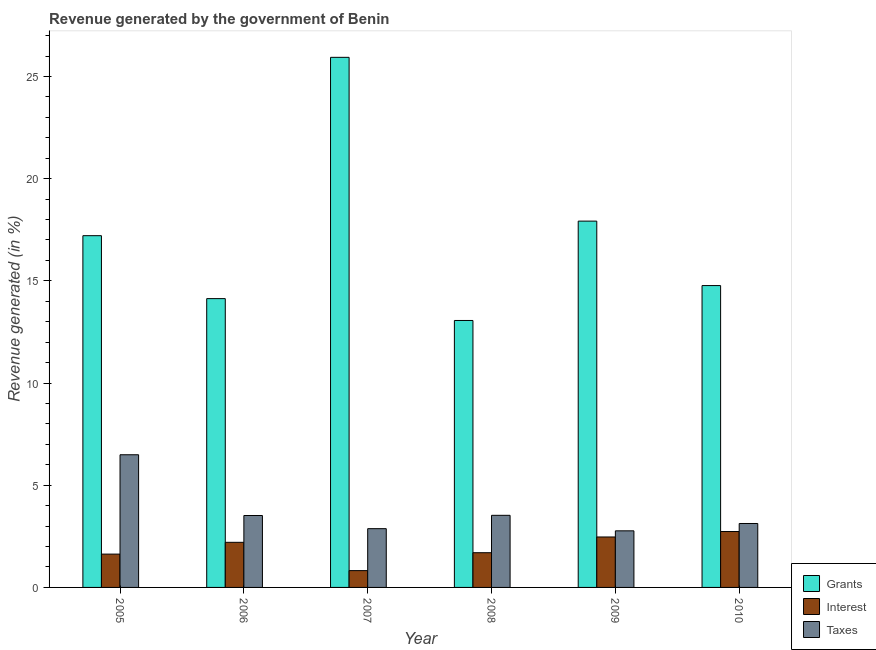Are the number of bars on each tick of the X-axis equal?
Your response must be concise. Yes. What is the percentage of revenue generated by grants in 2010?
Your answer should be compact. 14.77. Across all years, what is the maximum percentage of revenue generated by taxes?
Give a very brief answer. 6.49. Across all years, what is the minimum percentage of revenue generated by grants?
Keep it short and to the point. 13.06. In which year was the percentage of revenue generated by interest maximum?
Your answer should be compact. 2010. In which year was the percentage of revenue generated by interest minimum?
Provide a short and direct response. 2007. What is the total percentage of revenue generated by grants in the graph?
Provide a succinct answer. 103.03. What is the difference between the percentage of revenue generated by grants in 2008 and that in 2009?
Your answer should be compact. -4.86. What is the difference between the percentage of revenue generated by grants in 2006 and the percentage of revenue generated by interest in 2008?
Make the answer very short. 1.07. What is the average percentage of revenue generated by interest per year?
Give a very brief answer. 1.93. In the year 2007, what is the difference between the percentage of revenue generated by interest and percentage of revenue generated by grants?
Provide a succinct answer. 0. What is the ratio of the percentage of revenue generated by interest in 2005 to that in 2010?
Offer a very short reply. 0.6. What is the difference between the highest and the second highest percentage of revenue generated by taxes?
Provide a succinct answer. 2.96. What is the difference between the highest and the lowest percentage of revenue generated by grants?
Keep it short and to the point. 12.87. In how many years, is the percentage of revenue generated by grants greater than the average percentage of revenue generated by grants taken over all years?
Keep it short and to the point. 3. Is the sum of the percentage of revenue generated by taxes in 2006 and 2009 greater than the maximum percentage of revenue generated by interest across all years?
Your response must be concise. No. What does the 1st bar from the left in 2008 represents?
Ensure brevity in your answer.  Grants. What does the 2nd bar from the right in 2007 represents?
Ensure brevity in your answer.  Interest. How many bars are there?
Give a very brief answer. 18. How many years are there in the graph?
Offer a very short reply. 6. Are the values on the major ticks of Y-axis written in scientific E-notation?
Your answer should be very brief. No. Does the graph contain any zero values?
Give a very brief answer. No. Does the graph contain grids?
Keep it short and to the point. No. What is the title of the graph?
Provide a short and direct response. Revenue generated by the government of Benin. What is the label or title of the X-axis?
Ensure brevity in your answer.  Year. What is the label or title of the Y-axis?
Provide a succinct answer. Revenue generated (in %). What is the Revenue generated (in %) of Grants in 2005?
Offer a very short reply. 17.21. What is the Revenue generated (in %) of Interest in 2005?
Your answer should be compact. 1.63. What is the Revenue generated (in %) of Taxes in 2005?
Make the answer very short. 6.49. What is the Revenue generated (in %) of Grants in 2006?
Ensure brevity in your answer.  14.13. What is the Revenue generated (in %) of Interest in 2006?
Offer a very short reply. 2.21. What is the Revenue generated (in %) in Taxes in 2006?
Keep it short and to the point. 3.52. What is the Revenue generated (in %) of Grants in 2007?
Your response must be concise. 25.94. What is the Revenue generated (in %) in Interest in 2007?
Provide a short and direct response. 0.82. What is the Revenue generated (in %) of Taxes in 2007?
Offer a terse response. 2.88. What is the Revenue generated (in %) in Grants in 2008?
Offer a very short reply. 13.06. What is the Revenue generated (in %) of Interest in 2008?
Provide a short and direct response. 1.7. What is the Revenue generated (in %) of Taxes in 2008?
Keep it short and to the point. 3.53. What is the Revenue generated (in %) of Grants in 2009?
Keep it short and to the point. 17.92. What is the Revenue generated (in %) in Interest in 2009?
Offer a terse response. 2.47. What is the Revenue generated (in %) of Taxes in 2009?
Your answer should be compact. 2.77. What is the Revenue generated (in %) of Grants in 2010?
Your answer should be compact. 14.77. What is the Revenue generated (in %) in Interest in 2010?
Provide a short and direct response. 2.74. What is the Revenue generated (in %) in Taxes in 2010?
Make the answer very short. 3.13. Across all years, what is the maximum Revenue generated (in %) in Grants?
Keep it short and to the point. 25.94. Across all years, what is the maximum Revenue generated (in %) in Interest?
Give a very brief answer. 2.74. Across all years, what is the maximum Revenue generated (in %) of Taxes?
Make the answer very short. 6.49. Across all years, what is the minimum Revenue generated (in %) in Grants?
Your answer should be compact. 13.06. Across all years, what is the minimum Revenue generated (in %) of Interest?
Provide a short and direct response. 0.82. Across all years, what is the minimum Revenue generated (in %) of Taxes?
Your response must be concise. 2.77. What is the total Revenue generated (in %) in Grants in the graph?
Your response must be concise. 103.03. What is the total Revenue generated (in %) in Interest in the graph?
Keep it short and to the point. 11.56. What is the total Revenue generated (in %) of Taxes in the graph?
Provide a short and direct response. 22.31. What is the difference between the Revenue generated (in %) of Grants in 2005 and that in 2006?
Provide a short and direct response. 3.08. What is the difference between the Revenue generated (in %) of Interest in 2005 and that in 2006?
Make the answer very short. -0.58. What is the difference between the Revenue generated (in %) of Taxes in 2005 and that in 2006?
Keep it short and to the point. 2.97. What is the difference between the Revenue generated (in %) in Grants in 2005 and that in 2007?
Provide a succinct answer. -8.73. What is the difference between the Revenue generated (in %) of Interest in 2005 and that in 2007?
Ensure brevity in your answer.  0.81. What is the difference between the Revenue generated (in %) of Taxes in 2005 and that in 2007?
Offer a very short reply. 3.62. What is the difference between the Revenue generated (in %) in Grants in 2005 and that in 2008?
Give a very brief answer. 4.15. What is the difference between the Revenue generated (in %) of Interest in 2005 and that in 2008?
Your answer should be very brief. -0.07. What is the difference between the Revenue generated (in %) in Taxes in 2005 and that in 2008?
Your answer should be very brief. 2.96. What is the difference between the Revenue generated (in %) of Grants in 2005 and that in 2009?
Offer a very short reply. -0.71. What is the difference between the Revenue generated (in %) of Interest in 2005 and that in 2009?
Your answer should be very brief. -0.84. What is the difference between the Revenue generated (in %) of Taxes in 2005 and that in 2009?
Provide a succinct answer. 3.72. What is the difference between the Revenue generated (in %) of Grants in 2005 and that in 2010?
Your response must be concise. 2.44. What is the difference between the Revenue generated (in %) in Interest in 2005 and that in 2010?
Your answer should be very brief. -1.1. What is the difference between the Revenue generated (in %) in Taxes in 2005 and that in 2010?
Provide a succinct answer. 3.36. What is the difference between the Revenue generated (in %) of Grants in 2006 and that in 2007?
Provide a short and direct response. -11.81. What is the difference between the Revenue generated (in %) of Interest in 2006 and that in 2007?
Provide a succinct answer. 1.38. What is the difference between the Revenue generated (in %) of Taxes in 2006 and that in 2007?
Keep it short and to the point. 0.64. What is the difference between the Revenue generated (in %) of Grants in 2006 and that in 2008?
Offer a terse response. 1.07. What is the difference between the Revenue generated (in %) of Interest in 2006 and that in 2008?
Make the answer very short. 0.51. What is the difference between the Revenue generated (in %) in Taxes in 2006 and that in 2008?
Provide a short and direct response. -0.01. What is the difference between the Revenue generated (in %) of Grants in 2006 and that in 2009?
Make the answer very short. -3.79. What is the difference between the Revenue generated (in %) of Interest in 2006 and that in 2009?
Ensure brevity in your answer.  -0.26. What is the difference between the Revenue generated (in %) in Grants in 2006 and that in 2010?
Your answer should be compact. -0.64. What is the difference between the Revenue generated (in %) in Interest in 2006 and that in 2010?
Your response must be concise. -0.53. What is the difference between the Revenue generated (in %) in Taxes in 2006 and that in 2010?
Your response must be concise. 0.39. What is the difference between the Revenue generated (in %) in Grants in 2007 and that in 2008?
Your answer should be compact. 12.87. What is the difference between the Revenue generated (in %) in Interest in 2007 and that in 2008?
Make the answer very short. -0.88. What is the difference between the Revenue generated (in %) in Taxes in 2007 and that in 2008?
Your response must be concise. -0.65. What is the difference between the Revenue generated (in %) in Grants in 2007 and that in 2009?
Your answer should be compact. 8.01. What is the difference between the Revenue generated (in %) in Interest in 2007 and that in 2009?
Provide a succinct answer. -1.65. What is the difference between the Revenue generated (in %) in Taxes in 2007 and that in 2009?
Give a very brief answer. 0.11. What is the difference between the Revenue generated (in %) of Grants in 2007 and that in 2010?
Your answer should be very brief. 11.17. What is the difference between the Revenue generated (in %) in Interest in 2007 and that in 2010?
Your answer should be compact. -1.91. What is the difference between the Revenue generated (in %) of Taxes in 2007 and that in 2010?
Ensure brevity in your answer.  -0.25. What is the difference between the Revenue generated (in %) in Grants in 2008 and that in 2009?
Your answer should be compact. -4.86. What is the difference between the Revenue generated (in %) in Interest in 2008 and that in 2009?
Your answer should be compact. -0.77. What is the difference between the Revenue generated (in %) in Taxes in 2008 and that in 2009?
Make the answer very short. 0.76. What is the difference between the Revenue generated (in %) of Grants in 2008 and that in 2010?
Make the answer very short. -1.71. What is the difference between the Revenue generated (in %) of Interest in 2008 and that in 2010?
Ensure brevity in your answer.  -1.04. What is the difference between the Revenue generated (in %) in Taxes in 2008 and that in 2010?
Keep it short and to the point. 0.4. What is the difference between the Revenue generated (in %) in Grants in 2009 and that in 2010?
Ensure brevity in your answer.  3.15. What is the difference between the Revenue generated (in %) in Interest in 2009 and that in 2010?
Make the answer very short. -0.27. What is the difference between the Revenue generated (in %) in Taxes in 2009 and that in 2010?
Make the answer very short. -0.36. What is the difference between the Revenue generated (in %) of Grants in 2005 and the Revenue generated (in %) of Interest in 2006?
Keep it short and to the point. 15. What is the difference between the Revenue generated (in %) of Grants in 2005 and the Revenue generated (in %) of Taxes in 2006?
Ensure brevity in your answer.  13.69. What is the difference between the Revenue generated (in %) of Interest in 2005 and the Revenue generated (in %) of Taxes in 2006?
Offer a terse response. -1.89. What is the difference between the Revenue generated (in %) of Grants in 2005 and the Revenue generated (in %) of Interest in 2007?
Give a very brief answer. 16.39. What is the difference between the Revenue generated (in %) in Grants in 2005 and the Revenue generated (in %) in Taxes in 2007?
Make the answer very short. 14.33. What is the difference between the Revenue generated (in %) in Interest in 2005 and the Revenue generated (in %) in Taxes in 2007?
Provide a succinct answer. -1.25. What is the difference between the Revenue generated (in %) of Grants in 2005 and the Revenue generated (in %) of Interest in 2008?
Offer a very short reply. 15.51. What is the difference between the Revenue generated (in %) of Grants in 2005 and the Revenue generated (in %) of Taxes in 2008?
Provide a succinct answer. 13.68. What is the difference between the Revenue generated (in %) of Interest in 2005 and the Revenue generated (in %) of Taxes in 2008?
Provide a short and direct response. -1.9. What is the difference between the Revenue generated (in %) in Grants in 2005 and the Revenue generated (in %) in Interest in 2009?
Your response must be concise. 14.74. What is the difference between the Revenue generated (in %) in Grants in 2005 and the Revenue generated (in %) in Taxes in 2009?
Ensure brevity in your answer.  14.44. What is the difference between the Revenue generated (in %) in Interest in 2005 and the Revenue generated (in %) in Taxes in 2009?
Make the answer very short. -1.14. What is the difference between the Revenue generated (in %) in Grants in 2005 and the Revenue generated (in %) in Interest in 2010?
Provide a short and direct response. 14.47. What is the difference between the Revenue generated (in %) in Grants in 2005 and the Revenue generated (in %) in Taxes in 2010?
Provide a succinct answer. 14.08. What is the difference between the Revenue generated (in %) of Interest in 2005 and the Revenue generated (in %) of Taxes in 2010?
Give a very brief answer. -1.5. What is the difference between the Revenue generated (in %) of Grants in 2006 and the Revenue generated (in %) of Interest in 2007?
Offer a terse response. 13.31. What is the difference between the Revenue generated (in %) of Grants in 2006 and the Revenue generated (in %) of Taxes in 2007?
Your response must be concise. 11.25. What is the difference between the Revenue generated (in %) in Interest in 2006 and the Revenue generated (in %) in Taxes in 2007?
Your response must be concise. -0.67. What is the difference between the Revenue generated (in %) of Grants in 2006 and the Revenue generated (in %) of Interest in 2008?
Make the answer very short. 12.43. What is the difference between the Revenue generated (in %) in Grants in 2006 and the Revenue generated (in %) in Taxes in 2008?
Make the answer very short. 10.6. What is the difference between the Revenue generated (in %) of Interest in 2006 and the Revenue generated (in %) of Taxes in 2008?
Offer a very short reply. -1.32. What is the difference between the Revenue generated (in %) in Grants in 2006 and the Revenue generated (in %) in Interest in 2009?
Ensure brevity in your answer.  11.66. What is the difference between the Revenue generated (in %) of Grants in 2006 and the Revenue generated (in %) of Taxes in 2009?
Ensure brevity in your answer.  11.36. What is the difference between the Revenue generated (in %) in Interest in 2006 and the Revenue generated (in %) in Taxes in 2009?
Your answer should be very brief. -0.56. What is the difference between the Revenue generated (in %) in Grants in 2006 and the Revenue generated (in %) in Interest in 2010?
Make the answer very short. 11.39. What is the difference between the Revenue generated (in %) of Grants in 2006 and the Revenue generated (in %) of Taxes in 2010?
Keep it short and to the point. 11. What is the difference between the Revenue generated (in %) of Interest in 2006 and the Revenue generated (in %) of Taxes in 2010?
Ensure brevity in your answer.  -0.92. What is the difference between the Revenue generated (in %) in Grants in 2007 and the Revenue generated (in %) in Interest in 2008?
Provide a short and direct response. 24.24. What is the difference between the Revenue generated (in %) of Grants in 2007 and the Revenue generated (in %) of Taxes in 2008?
Your answer should be very brief. 22.41. What is the difference between the Revenue generated (in %) in Interest in 2007 and the Revenue generated (in %) in Taxes in 2008?
Keep it short and to the point. -2.71. What is the difference between the Revenue generated (in %) in Grants in 2007 and the Revenue generated (in %) in Interest in 2009?
Keep it short and to the point. 23.47. What is the difference between the Revenue generated (in %) in Grants in 2007 and the Revenue generated (in %) in Taxes in 2009?
Your response must be concise. 23.17. What is the difference between the Revenue generated (in %) of Interest in 2007 and the Revenue generated (in %) of Taxes in 2009?
Your response must be concise. -1.95. What is the difference between the Revenue generated (in %) of Grants in 2007 and the Revenue generated (in %) of Interest in 2010?
Provide a short and direct response. 23.2. What is the difference between the Revenue generated (in %) of Grants in 2007 and the Revenue generated (in %) of Taxes in 2010?
Offer a terse response. 22.81. What is the difference between the Revenue generated (in %) in Interest in 2007 and the Revenue generated (in %) in Taxes in 2010?
Your answer should be compact. -2.31. What is the difference between the Revenue generated (in %) of Grants in 2008 and the Revenue generated (in %) of Interest in 2009?
Your response must be concise. 10.59. What is the difference between the Revenue generated (in %) in Grants in 2008 and the Revenue generated (in %) in Taxes in 2009?
Your response must be concise. 10.29. What is the difference between the Revenue generated (in %) in Interest in 2008 and the Revenue generated (in %) in Taxes in 2009?
Offer a terse response. -1.07. What is the difference between the Revenue generated (in %) in Grants in 2008 and the Revenue generated (in %) in Interest in 2010?
Your answer should be very brief. 10.33. What is the difference between the Revenue generated (in %) of Grants in 2008 and the Revenue generated (in %) of Taxes in 2010?
Keep it short and to the point. 9.93. What is the difference between the Revenue generated (in %) in Interest in 2008 and the Revenue generated (in %) in Taxes in 2010?
Give a very brief answer. -1.43. What is the difference between the Revenue generated (in %) of Grants in 2009 and the Revenue generated (in %) of Interest in 2010?
Provide a short and direct response. 15.19. What is the difference between the Revenue generated (in %) of Grants in 2009 and the Revenue generated (in %) of Taxes in 2010?
Offer a terse response. 14.79. What is the difference between the Revenue generated (in %) in Interest in 2009 and the Revenue generated (in %) in Taxes in 2010?
Your answer should be very brief. -0.66. What is the average Revenue generated (in %) in Grants per year?
Keep it short and to the point. 17.17. What is the average Revenue generated (in %) in Interest per year?
Your response must be concise. 1.93. What is the average Revenue generated (in %) of Taxes per year?
Make the answer very short. 3.72. In the year 2005, what is the difference between the Revenue generated (in %) of Grants and Revenue generated (in %) of Interest?
Your response must be concise. 15.58. In the year 2005, what is the difference between the Revenue generated (in %) of Grants and Revenue generated (in %) of Taxes?
Your answer should be compact. 10.72. In the year 2005, what is the difference between the Revenue generated (in %) in Interest and Revenue generated (in %) in Taxes?
Ensure brevity in your answer.  -4.86. In the year 2006, what is the difference between the Revenue generated (in %) of Grants and Revenue generated (in %) of Interest?
Ensure brevity in your answer.  11.92. In the year 2006, what is the difference between the Revenue generated (in %) of Grants and Revenue generated (in %) of Taxes?
Keep it short and to the point. 10.61. In the year 2006, what is the difference between the Revenue generated (in %) in Interest and Revenue generated (in %) in Taxes?
Offer a very short reply. -1.31. In the year 2007, what is the difference between the Revenue generated (in %) of Grants and Revenue generated (in %) of Interest?
Your response must be concise. 25.11. In the year 2007, what is the difference between the Revenue generated (in %) in Grants and Revenue generated (in %) in Taxes?
Provide a short and direct response. 23.06. In the year 2007, what is the difference between the Revenue generated (in %) of Interest and Revenue generated (in %) of Taxes?
Your answer should be compact. -2.05. In the year 2008, what is the difference between the Revenue generated (in %) of Grants and Revenue generated (in %) of Interest?
Provide a succinct answer. 11.36. In the year 2008, what is the difference between the Revenue generated (in %) in Grants and Revenue generated (in %) in Taxes?
Your answer should be compact. 9.53. In the year 2008, what is the difference between the Revenue generated (in %) of Interest and Revenue generated (in %) of Taxes?
Provide a short and direct response. -1.83. In the year 2009, what is the difference between the Revenue generated (in %) of Grants and Revenue generated (in %) of Interest?
Your answer should be very brief. 15.45. In the year 2009, what is the difference between the Revenue generated (in %) in Grants and Revenue generated (in %) in Taxes?
Provide a short and direct response. 15.15. In the year 2009, what is the difference between the Revenue generated (in %) in Interest and Revenue generated (in %) in Taxes?
Give a very brief answer. -0.3. In the year 2010, what is the difference between the Revenue generated (in %) in Grants and Revenue generated (in %) in Interest?
Make the answer very short. 12.03. In the year 2010, what is the difference between the Revenue generated (in %) in Grants and Revenue generated (in %) in Taxes?
Make the answer very short. 11.64. In the year 2010, what is the difference between the Revenue generated (in %) in Interest and Revenue generated (in %) in Taxes?
Offer a terse response. -0.39. What is the ratio of the Revenue generated (in %) of Grants in 2005 to that in 2006?
Your answer should be very brief. 1.22. What is the ratio of the Revenue generated (in %) of Interest in 2005 to that in 2006?
Keep it short and to the point. 0.74. What is the ratio of the Revenue generated (in %) of Taxes in 2005 to that in 2006?
Your answer should be compact. 1.84. What is the ratio of the Revenue generated (in %) in Grants in 2005 to that in 2007?
Offer a very short reply. 0.66. What is the ratio of the Revenue generated (in %) in Interest in 2005 to that in 2007?
Your answer should be compact. 1.98. What is the ratio of the Revenue generated (in %) in Taxes in 2005 to that in 2007?
Your answer should be compact. 2.26. What is the ratio of the Revenue generated (in %) in Grants in 2005 to that in 2008?
Keep it short and to the point. 1.32. What is the ratio of the Revenue generated (in %) of Interest in 2005 to that in 2008?
Your answer should be very brief. 0.96. What is the ratio of the Revenue generated (in %) of Taxes in 2005 to that in 2008?
Keep it short and to the point. 1.84. What is the ratio of the Revenue generated (in %) in Grants in 2005 to that in 2009?
Provide a short and direct response. 0.96. What is the ratio of the Revenue generated (in %) in Interest in 2005 to that in 2009?
Make the answer very short. 0.66. What is the ratio of the Revenue generated (in %) of Taxes in 2005 to that in 2009?
Your answer should be compact. 2.34. What is the ratio of the Revenue generated (in %) of Grants in 2005 to that in 2010?
Your response must be concise. 1.17. What is the ratio of the Revenue generated (in %) of Interest in 2005 to that in 2010?
Provide a short and direct response. 0.6. What is the ratio of the Revenue generated (in %) of Taxes in 2005 to that in 2010?
Keep it short and to the point. 2.08. What is the ratio of the Revenue generated (in %) in Grants in 2006 to that in 2007?
Offer a very short reply. 0.54. What is the ratio of the Revenue generated (in %) in Interest in 2006 to that in 2007?
Keep it short and to the point. 2.68. What is the ratio of the Revenue generated (in %) in Taxes in 2006 to that in 2007?
Provide a succinct answer. 1.22. What is the ratio of the Revenue generated (in %) in Grants in 2006 to that in 2008?
Your answer should be very brief. 1.08. What is the ratio of the Revenue generated (in %) of Interest in 2006 to that in 2008?
Keep it short and to the point. 1.3. What is the ratio of the Revenue generated (in %) of Grants in 2006 to that in 2009?
Offer a terse response. 0.79. What is the ratio of the Revenue generated (in %) in Interest in 2006 to that in 2009?
Offer a very short reply. 0.89. What is the ratio of the Revenue generated (in %) of Taxes in 2006 to that in 2009?
Offer a terse response. 1.27. What is the ratio of the Revenue generated (in %) in Grants in 2006 to that in 2010?
Give a very brief answer. 0.96. What is the ratio of the Revenue generated (in %) of Interest in 2006 to that in 2010?
Your response must be concise. 0.81. What is the ratio of the Revenue generated (in %) of Taxes in 2006 to that in 2010?
Offer a terse response. 1.12. What is the ratio of the Revenue generated (in %) in Grants in 2007 to that in 2008?
Make the answer very short. 1.99. What is the ratio of the Revenue generated (in %) of Interest in 2007 to that in 2008?
Ensure brevity in your answer.  0.48. What is the ratio of the Revenue generated (in %) in Taxes in 2007 to that in 2008?
Offer a terse response. 0.81. What is the ratio of the Revenue generated (in %) in Grants in 2007 to that in 2009?
Make the answer very short. 1.45. What is the ratio of the Revenue generated (in %) of Interest in 2007 to that in 2009?
Keep it short and to the point. 0.33. What is the ratio of the Revenue generated (in %) in Taxes in 2007 to that in 2009?
Ensure brevity in your answer.  1.04. What is the ratio of the Revenue generated (in %) of Grants in 2007 to that in 2010?
Provide a short and direct response. 1.76. What is the ratio of the Revenue generated (in %) of Interest in 2007 to that in 2010?
Your answer should be very brief. 0.3. What is the ratio of the Revenue generated (in %) of Taxes in 2007 to that in 2010?
Provide a short and direct response. 0.92. What is the ratio of the Revenue generated (in %) of Grants in 2008 to that in 2009?
Your response must be concise. 0.73. What is the ratio of the Revenue generated (in %) of Interest in 2008 to that in 2009?
Your answer should be very brief. 0.69. What is the ratio of the Revenue generated (in %) of Taxes in 2008 to that in 2009?
Your answer should be very brief. 1.27. What is the ratio of the Revenue generated (in %) in Grants in 2008 to that in 2010?
Provide a short and direct response. 0.88. What is the ratio of the Revenue generated (in %) of Interest in 2008 to that in 2010?
Offer a very short reply. 0.62. What is the ratio of the Revenue generated (in %) in Taxes in 2008 to that in 2010?
Provide a short and direct response. 1.13. What is the ratio of the Revenue generated (in %) in Grants in 2009 to that in 2010?
Make the answer very short. 1.21. What is the ratio of the Revenue generated (in %) in Interest in 2009 to that in 2010?
Offer a terse response. 0.9. What is the ratio of the Revenue generated (in %) of Taxes in 2009 to that in 2010?
Your response must be concise. 0.89. What is the difference between the highest and the second highest Revenue generated (in %) of Grants?
Your response must be concise. 8.01. What is the difference between the highest and the second highest Revenue generated (in %) of Interest?
Provide a succinct answer. 0.27. What is the difference between the highest and the second highest Revenue generated (in %) of Taxes?
Provide a short and direct response. 2.96. What is the difference between the highest and the lowest Revenue generated (in %) in Grants?
Provide a short and direct response. 12.87. What is the difference between the highest and the lowest Revenue generated (in %) of Interest?
Provide a succinct answer. 1.91. What is the difference between the highest and the lowest Revenue generated (in %) in Taxes?
Provide a short and direct response. 3.72. 